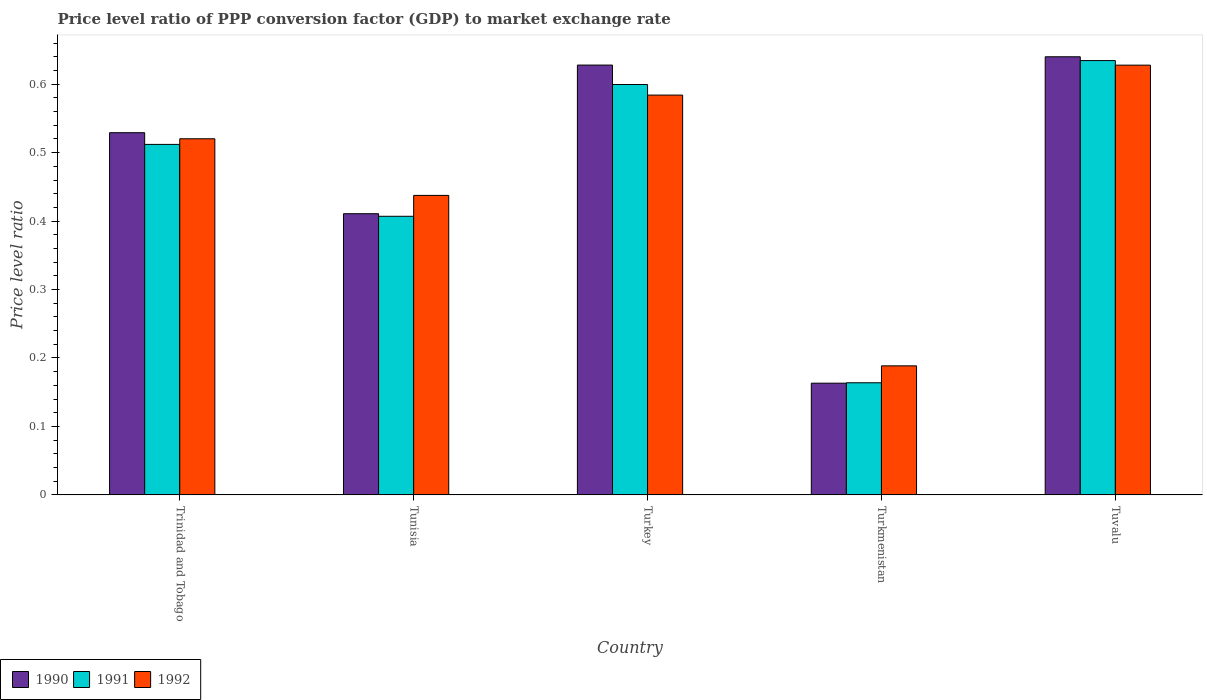How many groups of bars are there?
Your answer should be compact. 5. Are the number of bars per tick equal to the number of legend labels?
Provide a succinct answer. Yes. How many bars are there on the 5th tick from the right?
Keep it short and to the point. 3. What is the label of the 5th group of bars from the left?
Ensure brevity in your answer.  Tuvalu. What is the price level ratio in 1990 in Turkmenistan?
Your response must be concise. 0.16. Across all countries, what is the maximum price level ratio in 1991?
Keep it short and to the point. 0.63. Across all countries, what is the minimum price level ratio in 1991?
Your response must be concise. 0.16. In which country was the price level ratio in 1991 maximum?
Provide a short and direct response. Tuvalu. In which country was the price level ratio in 1991 minimum?
Provide a short and direct response. Turkmenistan. What is the total price level ratio in 1992 in the graph?
Provide a short and direct response. 2.36. What is the difference between the price level ratio in 1992 in Tunisia and that in Turkmenistan?
Your response must be concise. 0.25. What is the difference between the price level ratio in 1992 in Tuvalu and the price level ratio in 1990 in Tunisia?
Make the answer very short. 0.22. What is the average price level ratio in 1990 per country?
Provide a short and direct response. 0.47. What is the difference between the price level ratio of/in 1992 and price level ratio of/in 1990 in Turkmenistan?
Your answer should be very brief. 0.03. What is the ratio of the price level ratio in 1991 in Trinidad and Tobago to that in Tunisia?
Offer a very short reply. 1.26. Is the difference between the price level ratio in 1992 in Turkey and Turkmenistan greater than the difference between the price level ratio in 1990 in Turkey and Turkmenistan?
Your answer should be compact. No. What is the difference between the highest and the second highest price level ratio in 1992?
Keep it short and to the point. 0.04. What is the difference between the highest and the lowest price level ratio in 1992?
Ensure brevity in your answer.  0.44. In how many countries, is the price level ratio in 1992 greater than the average price level ratio in 1992 taken over all countries?
Offer a terse response. 3. Is the sum of the price level ratio in 1990 in Turkey and Tuvalu greater than the maximum price level ratio in 1992 across all countries?
Your answer should be very brief. Yes. Is it the case that in every country, the sum of the price level ratio in 1990 and price level ratio in 1991 is greater than the price level ratio in 1992?
Give a very brief answer. Yes. How many countries are there in the graph?
Offer a very short reply. 5. Are the values on the major ticks of Y-axis written in scientific E-notation?
Keep it short and to the point. No. Does the graph contain grids?
Your response must be concise. No. How are the legend labels stacked?
Provide a succinct answer. Horizontal. What is the title of the graph?
Ensure brevity in your answer.  Price level ratio of PPP conversion factor (GDP) to market exchange rate. What is the label or title of the X-axis?
Offer a very short reply. Country. What is the label or title of the Y-axis?
Ensure brevity in your answer.  Price level ratio. What is the Price level ratio of 1990 in Trinidad and Tobago?
Make the answer very short. 0.53. What is the Price level ratio in 1991 in Trinidad and Tobago?
Offer a terse response. 0.51. What is the Price level ratio of 1992 in Trinidad and Tobago?
Offer a terse response. 0.52. What is the Price level ratio in 1990 in Tunisia?
Ensure brevity in your answer.  0.41. What is the Price level ratio in 1991 in Tunisia?
Provide a short and direct response. 0.41. What is the Price level ratio of 1992 in Tunisia?
Your answer should be compact. 0.44. What is the Price level ratio in 1990 in Turkey?
Provide a succinct answer. 0.63. What is the Price level ratio in 1991 in Turkey?
Keep it short and to the point. 0.6. What is the Price level ratio of 1992 in Turkey?
Offer a very short reply. 0.58. What is the Price level ratio of 1990 in Turkmenistan?
Make the answer very short. 0.16. What is the Price level ratio of 1991 in Turkmenistan?
Your response must be concise. 0.16. What is the Price level ratio in 1992 in Turkmenistan?
Your answer should be very brief. 0.19. What is the Price level ratio in 1990 in Tuvalu?
Your response must be concise. 0.64. What is the Price level ratio of 1991 in Tuvalu?
Provide a succinct answer. 0.63. What is the Price level ratio of 1992 in Tuvalu?
Provide a succinct answer. 0.63. Across all countries, what is the maximum Price level ratio of 1990?
Keep it short and to the point. 0.64. Across all countries, what is the maximum Price level ratio in 1991?
Provide a short and direct response. 0.63. Across all countries, what is the maximum Price level ratio in 1992?
Your answer should be compact. 0.63. Across all countries, what is the minimum Price level ratio of 1990?
Offer a terse response. 0.16. Across all countries, what is the minimum Price level ratio in 1991?
Provide a short and direct response. 0.16. Across all countries, what is the minimum Price level ratio in 1992?
Provide a short and direct response. 0.19. What is the total Price level ratio in 1990 in the graph?
Your answer should be very brief. 2.37. What is the total Price level ratio of 1991 in the graph?
Offer a very short reply. 2.32. What is the total Price level ratio in 1992 in the graph?
Your response must be concise. 2.36. What is the difference between the Price level ratio of 1990 in Trinidad and Tobago and that in Tunisia?
Your response must be concise. 0.12. What is the difference between the Price level ratio of 1991 in Trinidad and Tobago and that in Tunisia?
Your answer should be very brief. 0.1. What is the difference between the Price level ratio in 1992 in Trinidad and Tobago and that in Tunisia?
Provide a succinct answer. 0.08. What is the difference between the Price level ratio in 1990 in Trinidad and Tobago and that in Turkey?
Your answer should be very brief. -0.1. What is the difference between the Price level ratio in 1991 in Trinidad and Tobago and that in Turkey?
Make the answer very short. -0.09. What is the difference between the Price level ratio of 1992 in Trinidad and Tobago and that in Turkey?
Your answer should be compact. -0.06. What is the difference between the Price level ratio in 1990 in Trinidad and Tobago and that in Turkmenistan?
Offer a terse response. 0.37. What is the difference between the Price level ratio of 1991 in Trinidad and Tobago and that in Turkmenistan?
Keep it short and to the point. 0.35. What is the difference between the Price level ratio in 1992 in Trinidad and Tobago and that in Turkmenistan?
Offer a terse response. 0.33. What is the difference between the Price level ratio in 1990 in Trinidad and Tobago and that in Tuvalu?
Ensure brevity in your answer.  -0.11. What is the difference between the Price level ratio of 1991 in Trinidad and Tobago and that in Tuvalu?
Ensure brevity in your answer.  -0.12. What is the difference between the Price level ratio of 1992 in Trinidad and Tobago and that in Tuvalu?
Your response must be concise. -0.11. What is the difference between the Price level ratio in 1990 in Tunisia and that in Turkey?
Keep it short and to the point. -0.22. What is the difference between the Price level ratio in 1991 in Tunisia and that in Turkey?
Ensure brevity in your answer.  -0.19. What is the difference between the Price level ratio in 1992 in Tunisia and that in Turkey?
Your answer should be very brief. -0.15. What is the difference between the Price level ratio of 1990 in Tunisia and that in Turkmenistan?
Provide a succinct answer. 0.25. What is the difference between the Price level ratio of 1991 in Tunisia and that in Turkmenistan?
Ensure brevity in your answer.  0.24. What is the difference between the Price level ratio in 1992 in Tunisia and that in Turkmenistan?
Your answer should be very brief. 0.25. What is the difference between the Price level ratio in 1990 in Tunisia and that in Tuvalu?
Your answer should be very brief. -0.23. What is the difference between the Price level ratio of 1991 in Tunisia and that in Tuvalu?
Your response must be concise. -0.23. What is the difference between the Price level ratio in 1992 in Tunisia and that in Tuvalu?
Keep it short and to the point. -0.19. What is the difference between the Price level ratio of 1990 in Turkey and that in Turkmenistan?
Ensure brevity in your answer.  0.46. What is the difference between the Price level ratio of 1991 in Turkey and that in Turkmenistan?
Your answer should be compact. 0.44. What is the difference between the Price level ratio in 1992 in Turkey and that in Turkmenistan?
Your answer should be compact. 0.4. What is the difference between the Price level ratio of 1990 in Turkey and that in Tuvalu?
Your response must be concise. -0.01. What is the difference between the Price level ratio of 1991 in Turkey and that in Tuvalu?
Offer a terse response. -0.03. What is the difference between the Price level ratio of 1992 in Turkey and that in Tuvalu?
Your response must be concise. -0.04. What is the difference between the Price level ratio of 1990 in Turkmenistan and that in Tuvalu?
Your response must be concise. -0.48. What is the difference between the Price level ratio of 1991 in Turkmenistan and that in Tuvalu?
Offer a terse response. -0.47. What is the difference between the Price level ratio of 1992 in Turkmenistan and that in Tuvalu?
Offer a very short reply. -0.44. What is the difference between the Price level ratio in 1990 in Trinidad and Tobago and the Price level ratio in 1991 in Tunisia?
Keep it short and to the point. 0.12. What is the difference between the Price level ratio of 1990 in Trinidad and Tobago and the Price level ratio of 1992 in Tunisia?
Ensure brevity in your answer.  0.09. What is the difference between the Price level ratio in 1991 in Trinidad and Tobago and the Price level ratio in 1992 in Tunisia?
Offer a terse response. 0.07. What is the difference between the Price level ratio of 1990 in Trinidad and Tobago and the Price level ratio of 1991 in Turkey?
Your response must be concise. -0.07. What is the difference between the Price level ratio in 1990 in Trinidad and Tobago and the Price level ratio in 1992 in Turkey?
Your answer should be very brief. -0.05. What is the difference between the Price level ratio of 1991 in Trinidad and Tobago and the Price level ratio of 1992 in Turkey?
Provide a succinct answer. -0.07. What is the difference between the Price level ratio of 1990 in Trinidad and Tobago and the Price level ratio of 1991 in Turkmenistan?
Keep it short and to the point. 0.37. What is the difference between the Price level ratio of 1990 in Trinidad and Tobago and the Price level ratio of 1992 in Turkmenistan?
Ensure brevity in your answer.  0.34. What is the difference between the Price level ratio of 1991 in Trinidad and Tobago and the Price level ratio of 1992 in Turkmenistan?
Offer a terse response. 0.32. What is the difference between the Price level ratio of 1990 in Trinidad and Tobago and the Price level ratio of 1991 in Tuvalu?
Provide a short and direct response. -0.11. What is the difference between the Price level ratio of 1990 in Trinidad and Tobago and the Price level ratio of 1992 in Tuvalu?
Provide a succinct answer. -0.1. What is the difference between the Price level ratio of 1991 in Trinidad and Tobago and the Price level ratio of 1992 in Tuvalu?
Make the answer very short. -0.12. What is the difference between the Price level ratio in 1990 in Tunisia and the Price level ratio in 1991 in Turkey?
Provide a short and direct response. -0.19. What is the difference between the Price level ratio in 1990 in Tunisia and the Price level ratio in 1992 in Turkey?
Your answer should be compact. -0.17. What is the difference between the Price level ratio in 1991 in Tunisia and the Price level ratio in 1992 in Turkey?
Provide a short and direct response. -0.18. What is the difference between the Price level ratio of 1990 in Tunisia and the Price level ratio of 1991 in Turkmenistan?
Make the answer very short. 0.25. What is the difference between the Price level ratio in 1990 in Tunisia and the Price level ratio in 1992 in Turkmenistan?
Keep it short and to the point. 0.22. What is the difference between the Price level ratio in 1991 in Tunisia and the Price level ratio in 1992 in Turkmenistan?
Offer a very short reply. 0.22. What is the difference between the Price level ratio in 1990 in Tunisia and the Price level ratio in 1991 in Tuvalu?
Give a very brief answer. -0.22. What is the difference between the Price level ratio of 1990 in Tunisia and the Price level ratio of 1992 in Tuvalu?
Offer a very short reply. -0.22. What is the difference between the Price level ratio of 1991 in Tunisia and the Price level ratio of 1992 in Tuvalu?
Keep it short and to the point. -0.22. What is the difference between the Price level ratio of 1990 in Turkey and the Price level ratio of 1991 in Turkmenistan?
Make the answer very short. 0.46. What is the difference between the Price level ratio in 1990 in Turkey and the Price level ratio in 1992 in Turkmenistan?
Offer a very short reply. 0.44. What is the difference between the Price level ratio of 1991 in Turkey and the Price level ratio of 1992 in Turkmenistan?
Provide a succinct answer. 0.41. What is the difference between the Price level ratio in 1990 in Turkey and the Price level ratio in 1991 in Tuvalu?
Provide a short and direct response. -0.01. What is the difference between the Price level ratio in 1990 in Turkey and the Price level ratio in 1992 in Tuvalu?
Your answer should be very brief. 0. What is the difference between the Price level ratio of 1991 in Turkey and the Price level ratio of 1992 in Tuvalu?
Give a very brief answer. -0.03. What is the difference between the Price level ratio in 1990 in Turkmenistan and the Price level ratio in 1991 in Tuvalu?
Your response must be concise. -0.47. What is the difference between the Price level ratio in 1990 in Turkmenistan and the Price level ratio in 1992 in Tuvalu?
Provide a succinct answer. -0.46. What is the difference between the Price level ratio of 1991 in Turkmenistan and the Price level ratio of 1992 in Tuvalu?
Ensure brevity in your answer.  -0.46. What is the average Price level ratio in 1990 per country?
Your answer should be compact. 0.47. What is the average Price level ratio in 1991 per country?
Your answer should be compact. 0.46. What is the average Price level ratio in 1992 per country?
Offer a very short reply. 0.47. What is the difference between the Price level ratio of 1990 and Price level ratio of 1991 in Trinidad and Tobago?
Offer a very short reply. 0.02. What is the difference between the Price level ratio of 1990 and Price level ratio of 1992 in Trinidad and Tobago?
Give a very brief answer. 0.01. What is the difference between the Price level ratio in 1991 and Price level ratio in 1992 in Trinidad and Tobago?
Keep it short and to the point. -0.01. What is the difference between the Price level ratio of 1990 and Price level ratio of 1991 in Tunisia?
Your answer should be compact. 0. What is the difference between the Price level ratio of 1990 and Price level ratio of 1992 in Tunisia?
Make the answer very short. -0.03. What is the difference between the Price level ratio in 1991 and Price level ratio in 1992 in Tunisia?
Give a very brief answer. -0.03. What is the difference between the Price level ratio of 1990 and Price level ratio of 1991 in Turkey?
Provide a short and direct response. 0.03. What is the difference between the Price level ratio of 1990 and Price level ratio of 1992 in Turkey?
Give a very brief answer. 0.04. What is the difference between the Price level ratio of 1991 and Price level ratio of 1992 in Turkey?
Keep it short and to the point. 0.02. What is the difference between the Price level ratio of 1990 and Price level ratio of 1991 in Turkmenistan?
Make the answer very short. -0. What is the difference between the Price level ratio of 1990 and Price level ratio of 1992 in Turkmenistan?
Provide a succinct answer. -0.03. What is the difference between the Price level ratio of 1991 and Price level ratio of 1992 in Turkmenistan?
Offer a terse response. -0.02. What is the difference between the Price level ratio in 1990 and Price level ratio in 1991 in Tuvalu?
Your answer should be very brief. 0.01. What is the difference between the Price level ratio of 1990 and Price level ratio of 1992 in Tuvalu?
Offer a terse response. 0.01. What is the difference between the Price level ratio of 1991 and Price level ratio of 1992 in Tuvalu?
Offer a terse response. 0.01. What is the ratio of the Price level ratio of 1990 in Trinidad and Tobago to that in Tunisia?
Give a very brief answer. 1.29. What is the ratio of the Price level ratio of 1991 in Trinidad and Tobago to that in Tunisia?
Your response must be concise. 1.26. What is the ratio of the Price level ratio in 1992 in Trinidad and Tobago to that in Tunisia?
Give a very brief answer. 1.19. What is the ratio of the Price level ratio of 1990 in Trinidad and Tobago to that in Turkey?
Make the answer very short. 0.84. What is the ratio of the Price level ratio of 1991 in Trinidad and Tobago to that in Turkey?
Your answer should be compact. 0.85. What is the ratio of the Price level ratio in 1992 in Trinidad and Tobago to that in Turkey?
Your answer should be compact. 0.89. What is the ratio of the Price level ratio in 1990 in Trinidad and Tobago to that in Turkmenistan?
Your response must be concise. 3.24. What is the ratio of the Price level ratio of 1991 in Trinidad and Tobago to that in Turkmenistan?
Ensure brevity in your answer.  3.13. What is the ratio of the Price level ratio in 1992 in Trinidad and Tobago to that in Turkmenistan?
Keep it short and to the point. 2.76. What is the ratio of the Price level ratio in 1990 in Trinidad and Tobago to that in Tuvalu?
Your answer should be compact. 0.83. What is the ratio of the Price level ratio of 1991 in Trinidad and Tobago to that in Tuvalu?
Keep it short and to the point. 0.81. What is the ratio of the Price level ratio of 1992 in Trinidad and Tobago to that in Tuvalu?
Keep it short and to the point. 0.83. What is the ratio of the Price level ratio in 1990 in Tunisia to that in Turkey?
Make the answer very short. 0.65. What is the ratio of the Price level ratio of 1991 in Tunisia to that in Turkey?
Offer a terse response. 0.68. What is the ratio of the Price level ratio of 1992 in Tunisia to that in Turkey?
Ensure brevity in your answer.  0.75. What is the ratio of the Price level ratio in 1990 in Tunisia to that in Turkmenistan?
Your answer should be very brief. 2.52. What is the ratio of the Price level ratio in 1991 in Tunisia to that in Turkmenistan?
Offer a very short reply. 2.48. What is the ratio of the Price level ratio in 1992 in Tunisia to that in Turkmenistan?
Make the answer very short. 2.32. What is the ratio of the Price level ratio of 1990 in Tunisia to that in Tuvalu?
Provide a succinct answer. 0.64. What is the ratio of the Price level ratio in 1991 in Tunisia to that in Tuvalu?
Your answer should be compact. 0.64. What is the ratio of the Price level ratio of 1992 in Tunisia to that in Tuvalu?
Keep it short and to the point. 0.7. What is the ratio of the Price level ratio in 1990 in Turkey to that in Turkmenistan?
Provide a succinct answer. 3.85. What is the ratio of the Price level ratio of 1991 in Turkey to that in Turkmenistan?
Provide a succinct answer. 3.66. What is the ratio of the Price level ratio of 1992 in Turkey to that in Turkmenistan?
Provide a succinct answer. 3.1. What is the ratio of the Price level ratio of 1990 in Turkey to that in Tuvalu?
Make the answer very short. 0.98. What is the ratio of the Price level ratio in 1991 in Turkey to that in Tuvalu?
Provide a short and direct response. 0.94. What is the ratio of the Price level ratio of 1992 in Turkey to that in Tuvalu?
Your answer should be very brief. 0.93. What is the ratio of the Price level ratio of 1990 in Turkmenistan to that in Tuvalu?
Your answer should be very brief. 0.26. What is the ratio of the Price level ratio of 1991 in Turkmenistan to that in Tuvalu?
Offer a terse response. 0.26. What is the ratio of the Price level ratio in 1992 in Turkmenistan to that in Tuvalu?
Offer a very short reply. 0.3. What is the difference between the highest and the second highest Price level ratio in 1990?
Your answer should be very brief. 0.01. What is the difference between the highest and the second highest Price level ratio in 1991?
Keep it short and to the point. 0.03. What is the difference between the highest and the second highest Price level ratio of 1992?
Provide a short and direct response. 0.04. What is the difference between the highest and the lowest Price level ratio of 1990?
Your answer should be very brief. 0.48. What is the difference between the highest and the lowest Price level ratio of 1991?
Provide a short and direct response. 0.47. What is the difference between the highest and the lowest Price level ratio in 1992?
Ensure brevity in your answer.  0.44. 